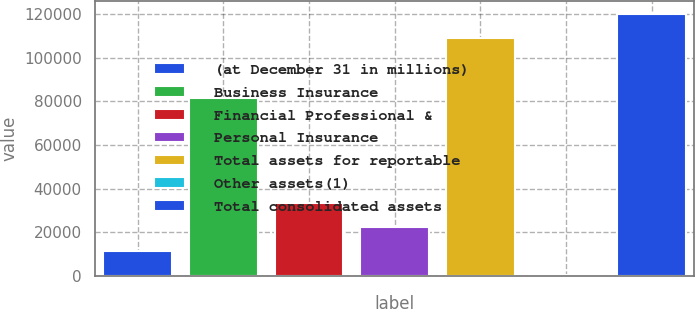Convert chart to OTSL. <chart><loc_0><loc_0><loc_500><loc_500><bar_chart><fcel>(at December 31 in millions)<fcel>Business Insurance<fcel>Financial Professional &<fcel>Personal Insurance<fcel>Total assets for reportable<fcel>Other assets(1)<fcel>Total consolidated assets<nl><fcel>11502.3<fcel>81705<fcel>33292.9<fcel>22397.6<fcel>108953<fcel>607<fcel>119848<nl></chart> 